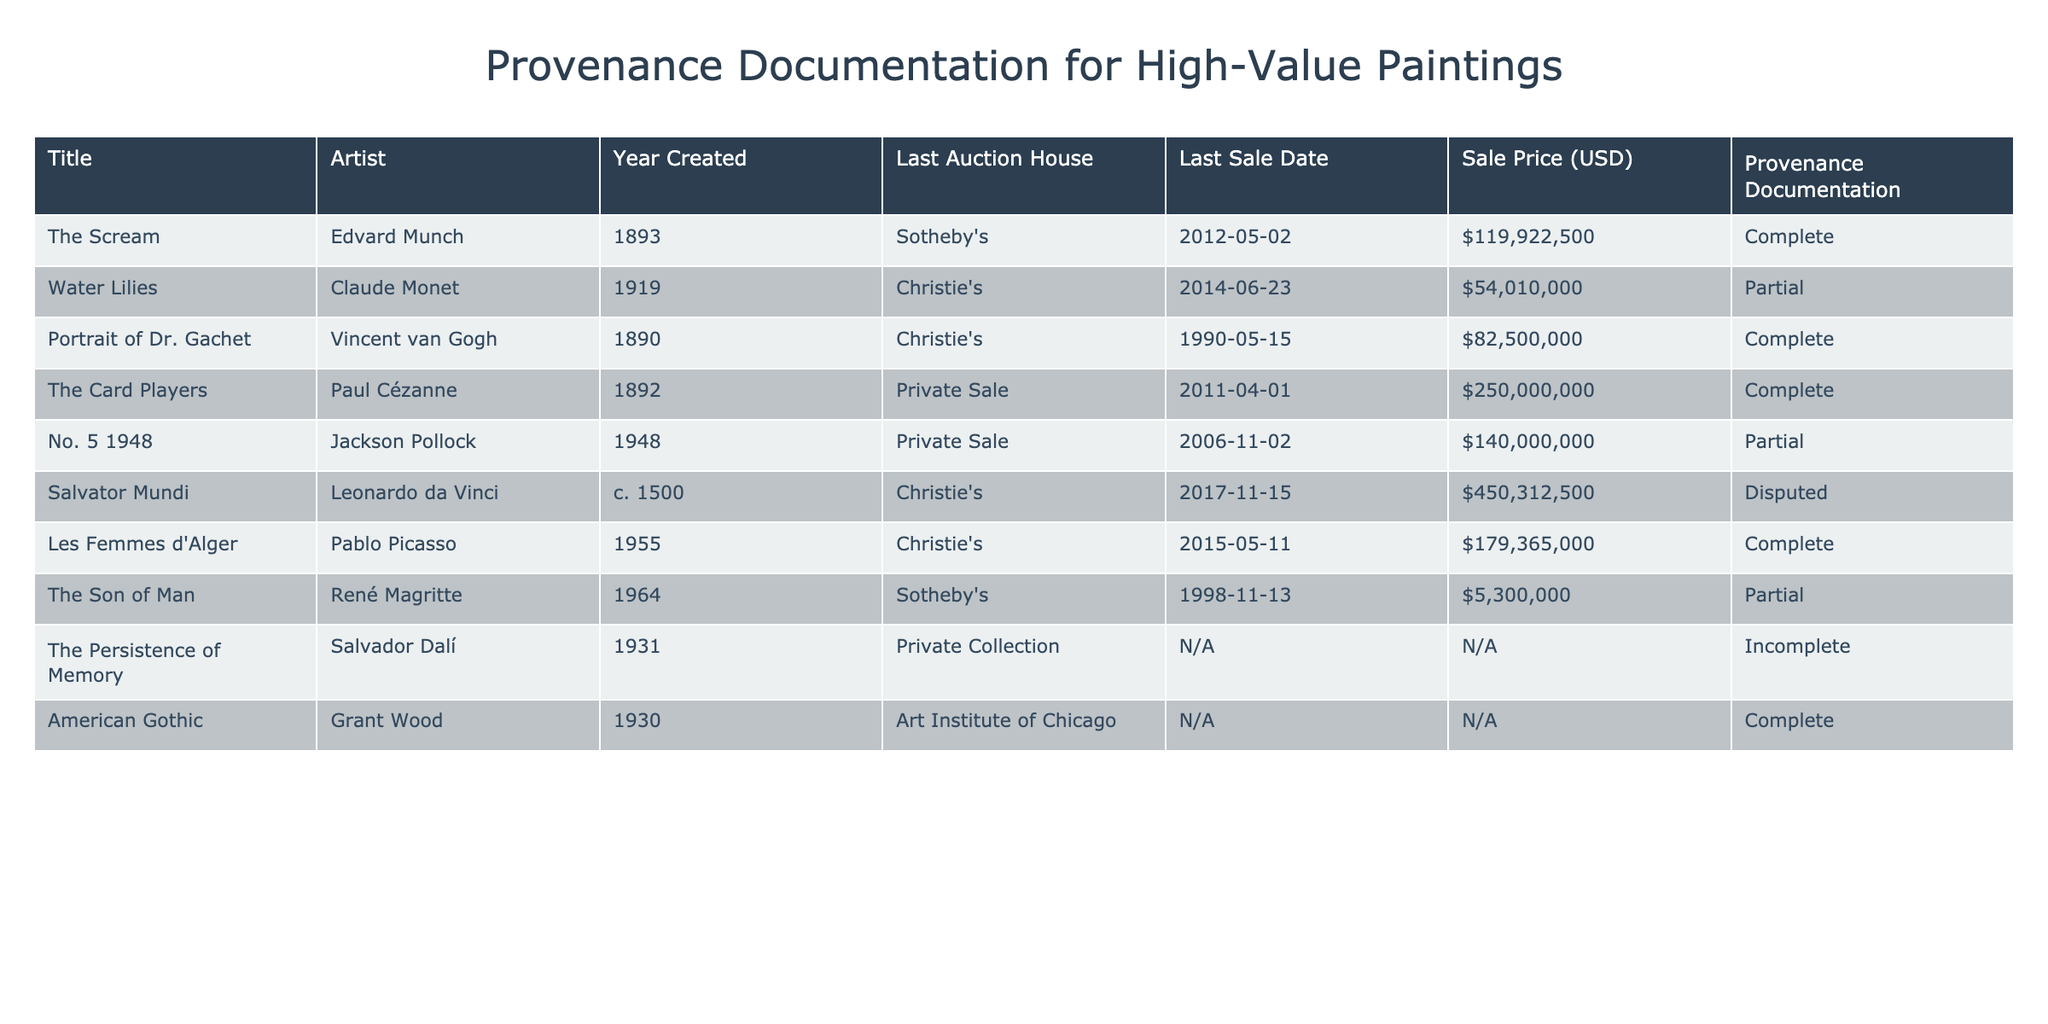What is the sale price of "The Scream"? According to the table, the sale price of "The Scream" by Edvard Munch is listed as $119,922,500.
Answer: $119,922,500 How many paintings have complete provenance documentation? The table specifies that there are four paintings with complete provenance documentation: "The Scream," "Portrait of Dr. Gachet," "The Card Players," and "Les Femmes d'Alger." Count confirms this.
Answer: 4 What is the sale price of the painting with the highest auction price? The painting sold for the highest price is "Salvator Mundi" by Leonardo da Vinci at $450,312,500, as indicated in the table.
Answer: $450,312,500 Is "Water Lilies" by Claude Monet sold at auction? The table shows that "Water Lilies" was sold at Christie's auction house on June 23, 2014, confirming that it was sold at auction.
Answer: Yes Which painting has incomplete provenance documentation and what is its sale price? The table indicates that "The Persistence of Memory" has incomplete provenance documentation and does not list a sale price.
Answer: Incomplete documentation, N/A What are the titles of paintings whose provenance is partial? The titles of the paintings with partial provenance documentation are "Water Lilies" and "No. 5 1948" as per the table.
Answer: Water Lilies, No. 5 1948 What is the total sale price of the paintings with complete provenance documentation? The total sale price of the four paintings with complete provenance documentation sums up as follows: $119,922,500 (The Scream) + $82,500,000 (Portrait of Dr. Gachet) + $250,000,000 (The Card Players) + $179,365,000 (Les Femmes d'Alger) = $631,787,500.
Answer: $631,787,500 Which auction house sold the most paintings listed in the table? The auction house Christie's sold three paintings (Water Lilies, Portrait of Dr. Gachet, Les Femmes d'Alger), which is more than any other listed auction house.
Answer: Christie's Is there any painting whose sale date is listed as N/A? Yes, the table shows two paintings, "The Persistence of Memory" and "American Gothic," with their sale dates listed as N/A.
Answer: Yes Identify the artist with the earliest creation year in the table. The earliest year of creation is 1500 by Leonardo da Vinci for the painting "Salvator Mundi," making him the earliest artist in this table.
Answer: Leonardo da Vinci What is the average sale price of all paintings regardless of provenance documentation? The relevant sale prices to consider are $119,922,500, $54,010,000, $82,500,000, $250,000,000, $140,000,000, $450,312,500, $179,365,000, $5,300,000, and N/A for the two that don't have. Summing these gives $1,138,110,000 from 8 relevant sales, so the average is $1,138,110,000 / 8 = $142,263,750.
Answer: $142,263,750 